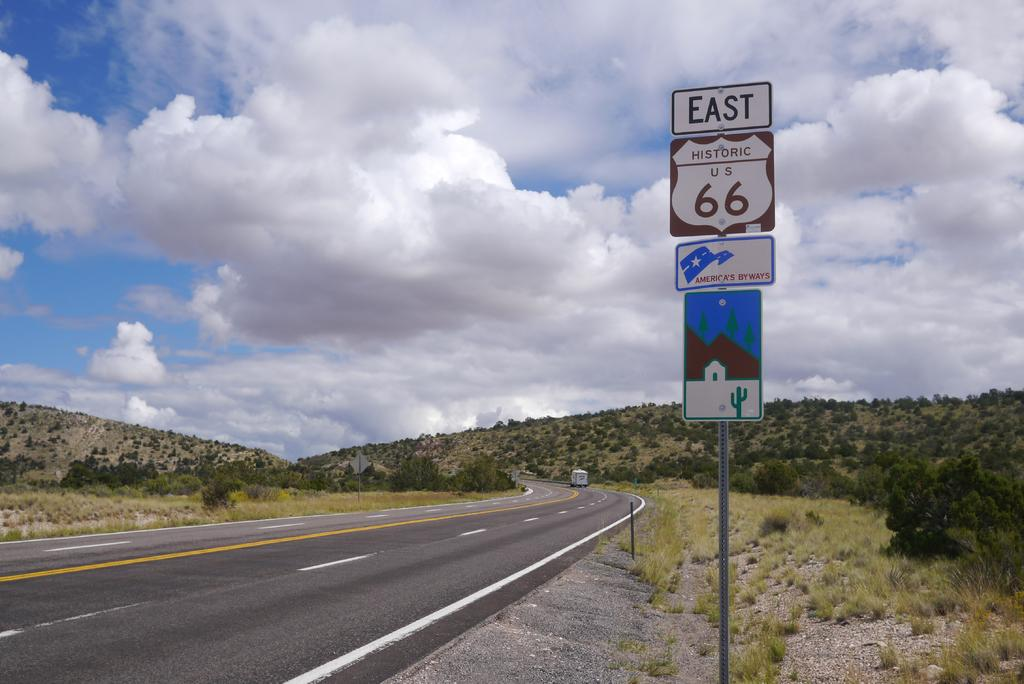<image>
Summarize the visual content of the image. the letters 66 that are on the sign 